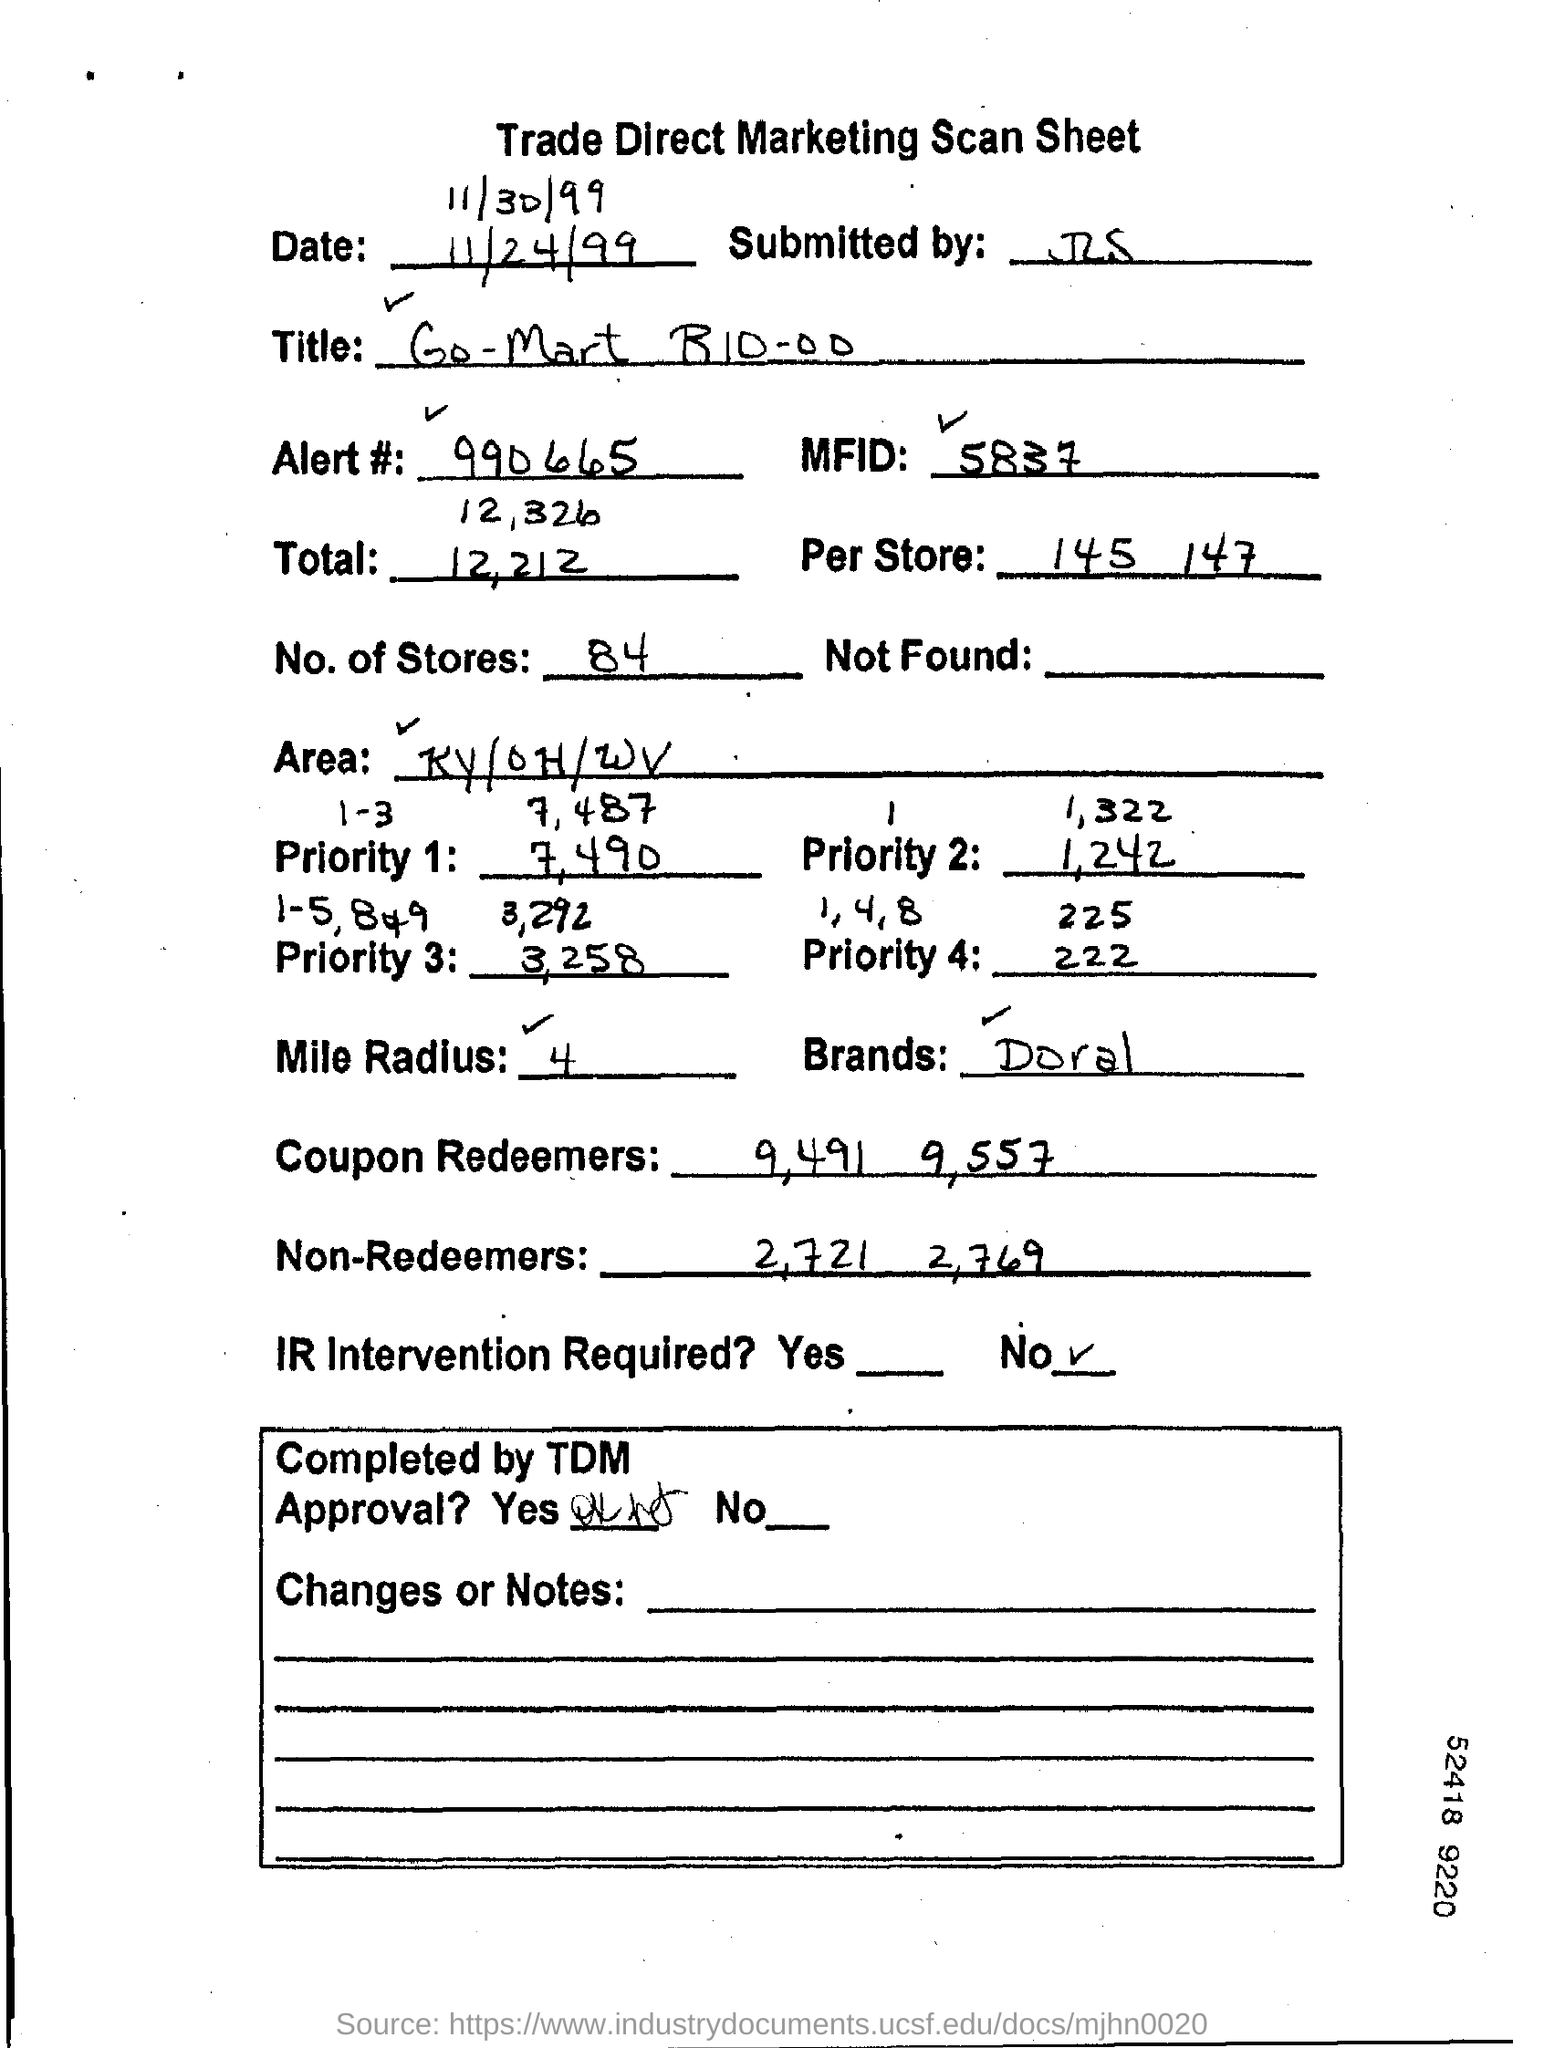What type of document is this?
Your answer should be very brief. Trade Direct Marketing Scan Sheet. Which brand's marketing details is this?
Your response must be concise. Doral. What is the "Alert" number given?
Your answer should be compact. 990665. What is the MFID number?
Provide a succinct answer. 5837. What is the "Per Store" number"?
Your answer should be very brief. 145  147. Mention the "No. of stores"?
Your answer should be very brief. 84. What is the "Area"?
Your answer should be compact. KY/OH/WV. What is the "Mile Radius"?
Your answer should be compact. 4. Is IR Intervention Required?
Keep it short and to the point. No. What is the "Brands" mentioned?
Your answer should be very brief. Doral. 